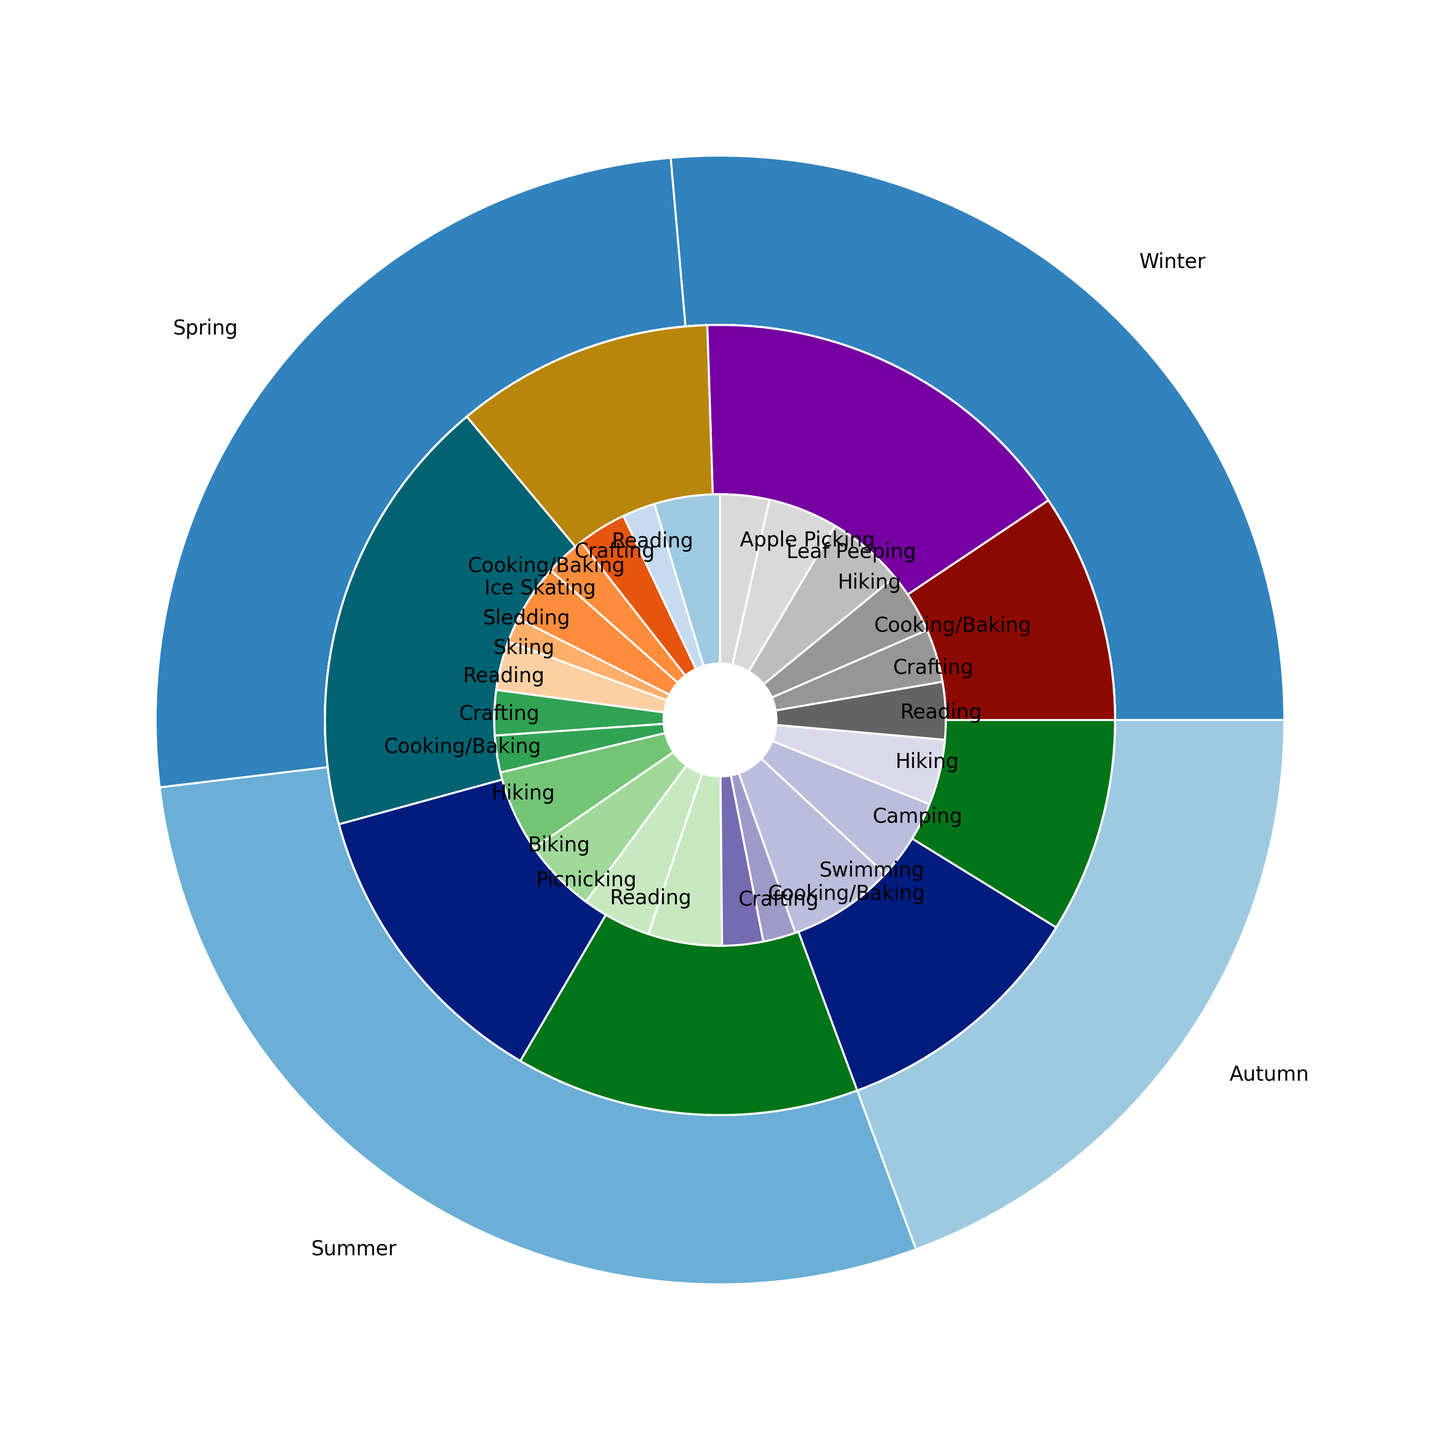What is the most popular activity in the winter season? Look at the segment for the winter season and identify which activity has the largest section within the winter pie slice.
Answer: Reading Which season has the highest total count of activities? Compare the sizes of the outer pie slices representing each season to determine the largest one.
Answer: Summer Is there any season where an outdoor activity is less popular than an indoor activity? Compare the inner pie slices for indoor and outdoor activities within each season to see if any indoor segment is larger than any outdoor segment.
Answer: Winter What is the overall count for Reading activities across all seasons? Add up the counts of Reading activities from all seasons: 80 (Winter) + 60 (Spring) + 90 (Summer) + 70 (Autumn).
Answer: 300 Which season has the lowest count of outdoor activities? Compare the sizes of the outer segments that represent outdoor activities for each season to determine the smallest one.
Answer: Winter How does the popularity of Ice Skating compare to Sledding in Winter? Compare the sizes of the segments within the winter slice representing Ice Skating and Sledding activities.
Answer: Sledding is more popular What is the combined count for all crafting activities across all seasons? Add up the counts for crafting activities in each season: 40 (Winter) + 55 (Spring) + 50 (Summer) + 65 (Autumn).
Answer: 210 Which activity in the Autumn season involves the second most number of participants? Look at the segments for the activities within the Autumn slice and identify the second largest one.
Answer: Hiking In which season is Cooking/Baking most popular? Compare the sizes of the Cooking/Baking segments across all seasons.
Answer: Autumn How many more people prefer Hiking in Spring compared to Autumn? Subtract the count of people who prefer Hiking in Autumn (95) from the count of people who prefer Hiking in Spring (100).
Answer: 5 